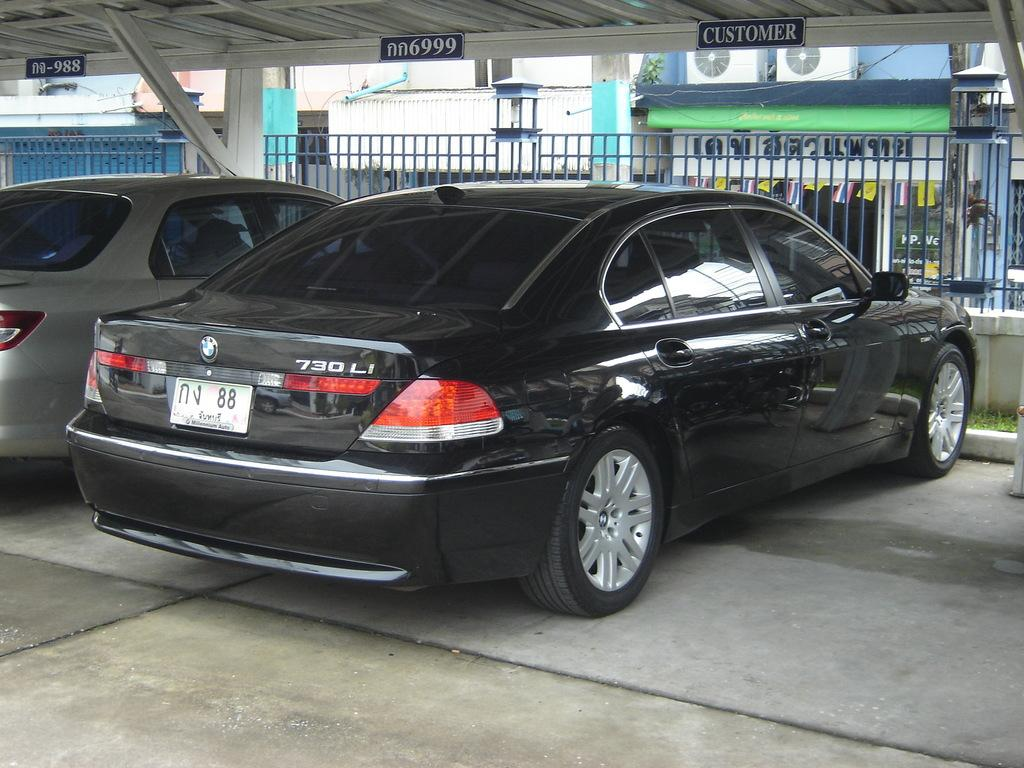How many cars are present in the image? There are two cars in the image. What is located behind the cars? There is a metal fence behind the cars. What can be seen beyond the metal fence? There is a store visible behind the metal fence. How many doors can be seen on the dolls in the image? There are no dolls present in the image, so the number of doors on dolls cannot be determined. 